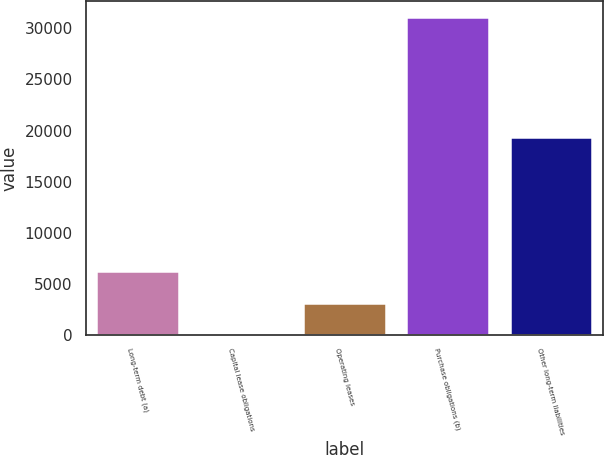Convert chart. <chart><loc_0><loc_0><loc_500><loc_500><bar_chart><fcel>Long-term debt (a)<fcel>Capital lease obligations<fcel>Operating leases<fcel>Purchase obligations (b)<fcel>Other long-term liabilities<nl><fcel>6249<fcel>31<fcel>3140<fcel>31121<fcel>19358<nl></chart> 